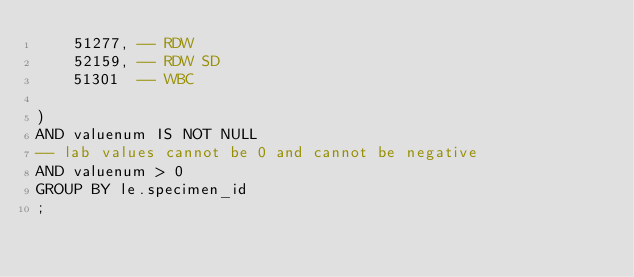<code> <loc_0><loc_0><loc_500><loc_500><_SQL_>    51277, -- RDW
    52159, -- RDW SD
    51301  -- WBC

)
AND valuenum IS NOT NULL
-- lab values cannot be 0 and cannot be negative
AND valuenum > 0
GROUP BY le.specimen_id
;
</code> 